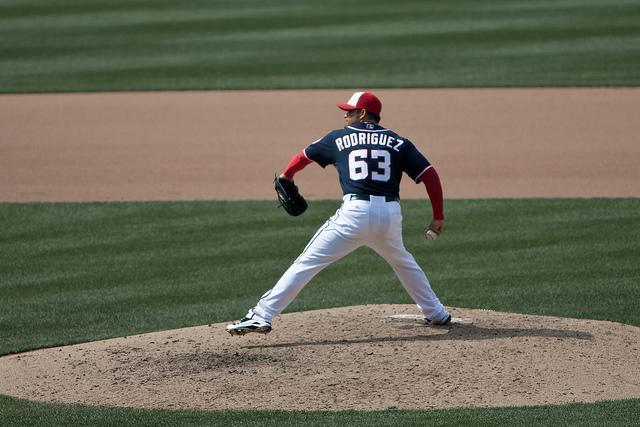How many bears are reflected on the water?
Give a very brief answer. 0. 